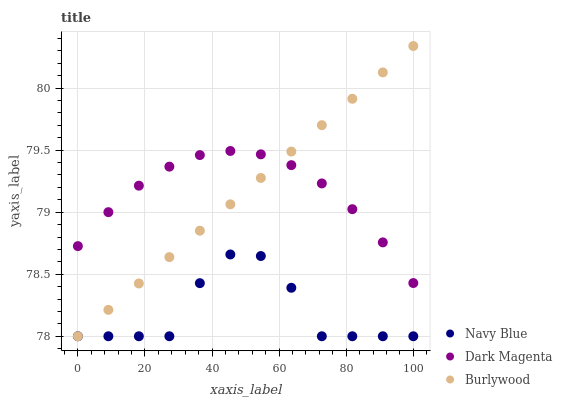Does Navy Blue have the minimum area under the curve?
Answer yes or no. Yes. Does Dark Magenta have the maximum area under the curve?
Answer yes or no. Yes. Does Dark Magenta have the minimum area under the curve?
Answer yes or no. No. Does Navy Blue have the maximum area under the curve?
Answer yes or no. No. Is Burlywood the smoothest?
Answer yes or no. Yes. Is Navy Blue the roughest?
Answer yes or no. Yes. Is Dark Magenta the smoothest?
Answer yes or no. No. Is Dark Magenta the roughest?
Answer yes or no. No. Does Burlywood have the lowest value?
Answer yes or no. Yes. Does Dark Magenta have the lowest value?
Answer yes or no. No. Does Burlywood have the highest value?
Answer yes or no. Yes. Does Dark Magenta have the highest value?
Answer yes or no. No. Is Navy Blue less than Dark Magenta?
Answer yes or no. Yes. Is Dark Magenta greater than Navy Blue?
Answer yes or no. Yes. Does Dark Magenta intersect Burlywood?
Answer yes or no. Yes. Is Dark Magenta less than Burlywood?
Answer yes or no. No. Is Dark Magenta greater than Burlywood?
Answer yes or no. No. Does Navy Blue intersect Dark Magenta?
Answer yes or no. No. 